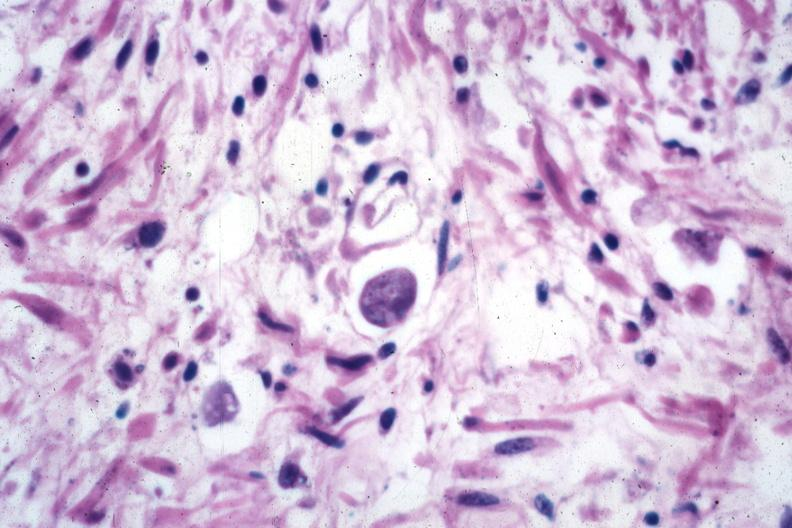s amebiasis present?
Answer the question using a single word or phrase. Yes 